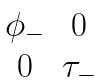<formula> <loc_0><loc_0><loc_500><loc_500>\begin{matrix} \phi _ { - } & 0 \\ 0 & \tau _ { - } \end{matrix}</formula> 